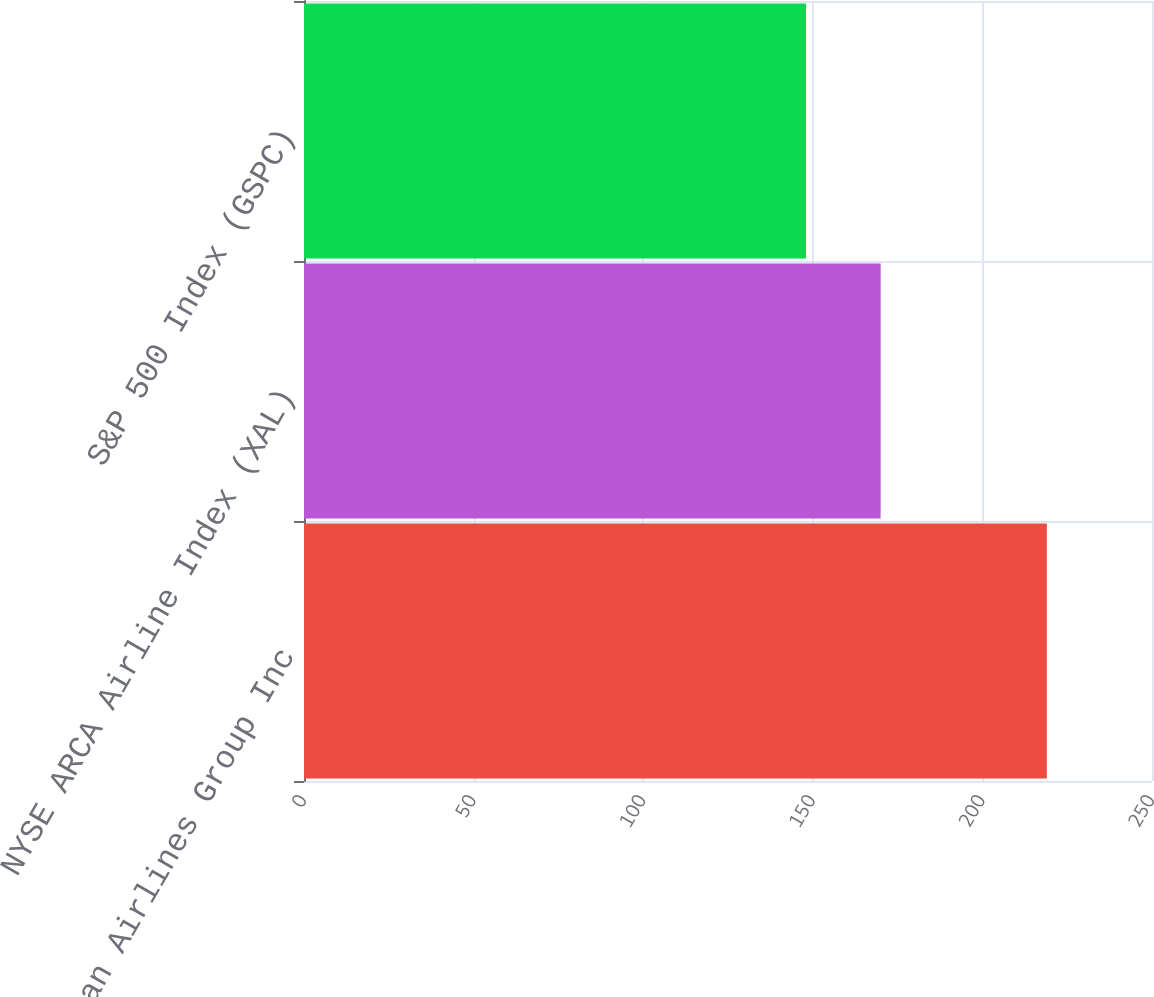Convert chart. <chart><loc_0><loc_0><loc_500><loc_500><bar_chart><fcel>American Airlines Group Inc<fcel>NYSE ARCA Airline Index (XAL)<fcel>S&P 500 Index (GSPC)<nl><fcel>219<fcel>170<fcel>148<nl></chart> 